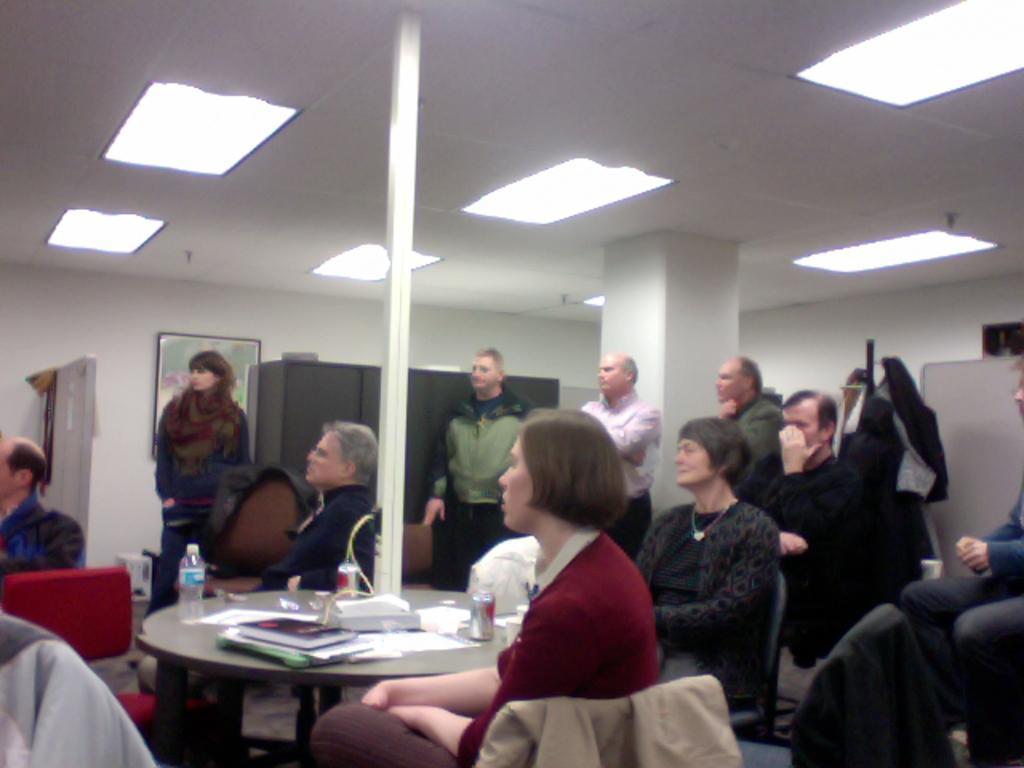Describe this image in one or two sentences. In this image we can see this people are sitting near table and this people are standing. We can see bottle, tins and books on the table. In the background we can see photo frame on wall, cupboards and lights on ceiling. 